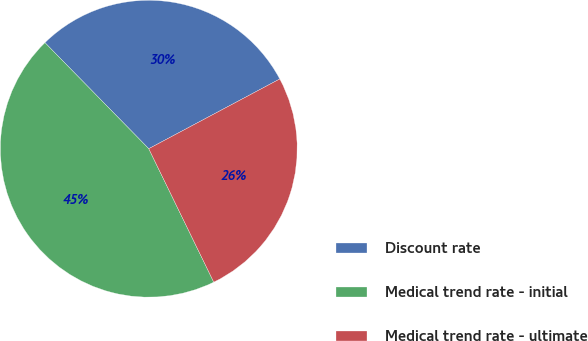<chart> <loc_0><loc_0><loc_500><loc_500><pie_chart><fcel>Discount rate<fcel>Medical trend rate - initial<fcel>Medical trend rate - ultimate<nl><fcel>29.55%<fcel>44.89%<fcel>25.57%<nl></chart> 